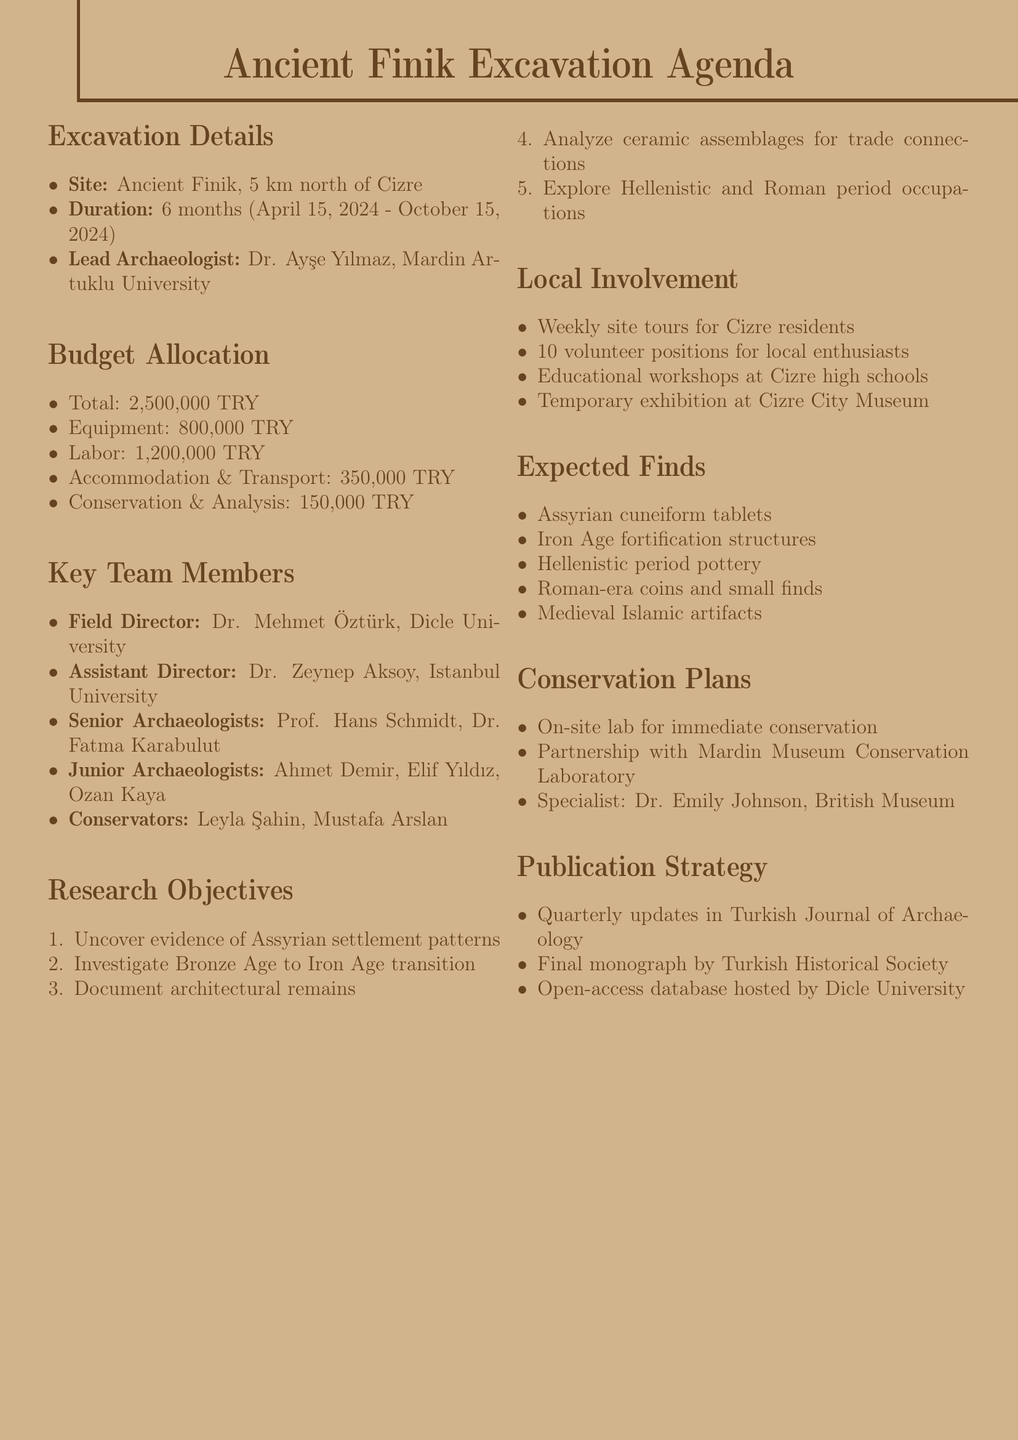what is the location of the excavation site? The excavation site is located 5 km north of Cizre, Şırnak Province.
Answer: 5 km north of Cizre, Şırnak Province who is the lead archaeologist? The document specifies that the lead archaeologist is Dr. Ayşe Yılmaz from Mardin Artuklu University.
Answer: Dr. Ayşe Yılmaz what is the total budget for the excavation? The total budget allocated for the excavation is clearly stated in the document.
Answer: 2,500,000 TRY how long will the excavation last? The duration of the excavation is noted in the document as a specific time frame.
Answer: 6 months who is responsible for field direction? The document lists Dr. Mehmet Öztürk as the Field Director.
Answer: Dr. Mehmet Öztürk what type of artifacts are expected to be found? The document provides a list of expected finds, which includes several types of artifacts.
Answer: Assyrian cuneiform tablets which institution is partnering for conservation plans? The document mentions that the conservation will be a collaborative effort with a specific institution.
Answer: Mardin Museum Conservation Laboratory when is the excavation scheduled to start? The start date for the excavation is specified in the document.
Answer: April 15, 2024 how many volunteer positions are available? The number of volunteer positions for local history enthusiasts is explicitly mentioned in the document.
Answer: 10 positions 